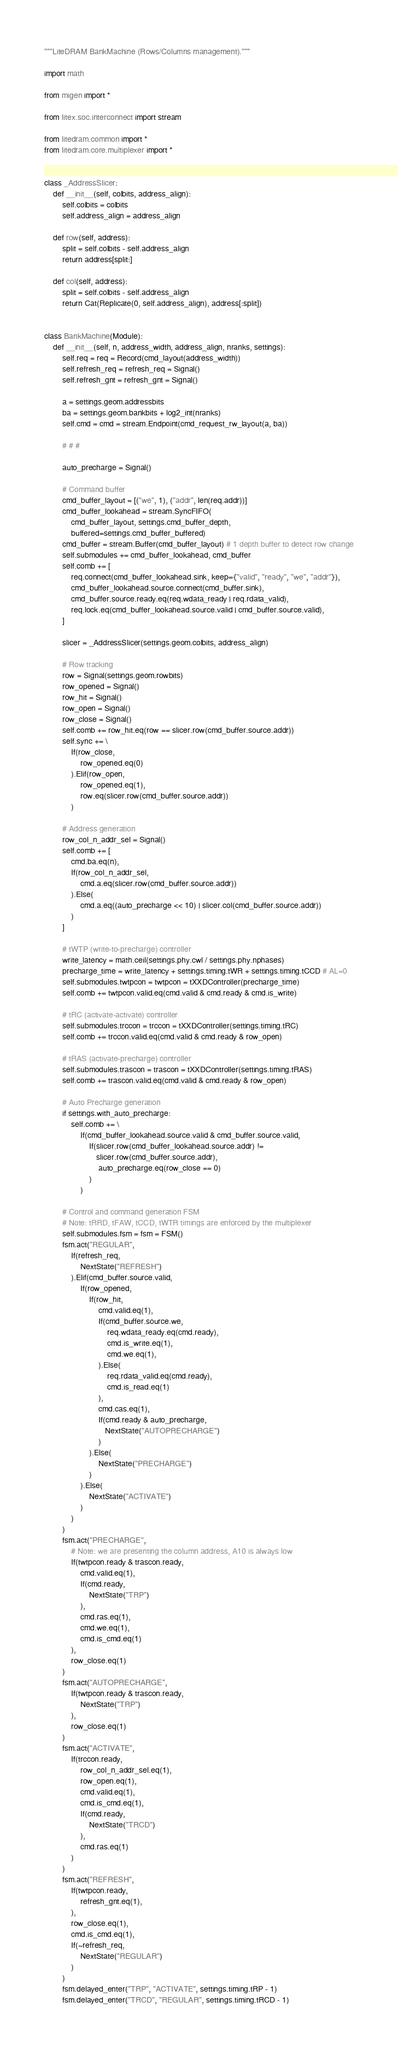<code> <loc_0><loc_0><loc_500><loc_500><_Python_>"""LiteDRAM BankMachine (Rows/Columns management)."""

import math

from migen import *

from litex.soc.interconnect import stream

from litedram.common import *
from litedram.core.multiplexer import *


class _AddressSlicer:
    def __init__(self, colbits, address_align):
        self.colbits = colbits
        self.address_align = address_align

    def row(self, address):
        split = self.colbits - self.address_align
        return address[split:]

    def col(self, address):
        split = self.colbits - self.address_align
        return Cat(Replicate(0, self.address_align), address[:split])


class BankMachine(Module):
    def __init__(self, n, address_width, address_align, nranks, settings):
        self.req = req = Record(cmd_layout(address_width))
        self.refresh_req = refresh_req = Signal()
        self.refresh_gnt = refresh_gnt = Signal()

        a = settings.geom.addressbits
        ba = settings.geom.bankbits + log2_int(nranks)
        self.cmd = cmd = stream.Endpoint(cmd_request_rw_layout(a, ba))

        # # #

        auto_precharge = Signal()

        # Command buffer
        cmd_buffer_layout = [("we", 1), ("addr", len(req.addr))]
        cmd_buffer_lookahead = stream.SyncFIFO(
            cmd_buffer_layout, settings.cmd_buffer_depth,
            buffered=settings.cmd_buffer_buffered)
        cmd_buffer = stream.Buffer(cmd_buffer_layout) # 1 depth buffer to detect row change
        self.submodules += cmd_buffer_lookahead, cmd_buffer
        self.comb += [
            req.connect(cmd_buffer_lookahead.sink, keep={"valid", "ready", "we", "addr"}),
            cmd_buffer_lookahead.source.connect(cmd_buffer.sink),
            cmd_buffer.source.ready.eq(req.wdata_ready | req.rdata_valid),
            req.lock.eq(cmd_buffer_lookahead.source.valid | cmd_buffer.source.valid),
        ]

        slicer = _AddressSlicer(settings.geom.colbits, address_align)

        # Row tracking
        row = Signal(settings.geom.rowbits)
        row_opened = Signal()
        row_hit = Signal()
        row_open = Signal()
        row_close = Signal()
        self.comb += row_hit.eq(row == slicer.row(cmd_buffer.source.addr))
        self.sync += \
            If(row_close,
                row_opened.eq(0)
            ).Elif(row_open,
                row_opened.eq(1),
                row.eq(slicer.row(cmd_buffer.source.addr))
            )

        # Address generation
        row_col_n_addr_sel = Signal()
        self.comb += [
            cmd.ba.eq(n),
            If(row_col_n_addr_sel,
                cmd.a.eq(slicer.row(cmd_buffer.source.addr))
            ).Else(
                cmd.a.eq((auto_precharge << 10) | slicer.col(cmd_buffer.source.addr))
            )
        ]

        # tWTP (write-to-precharge) controller
        write_latency = math.ceil(settings.phy.cwl / settings.phy.nphases)
        precharge_time = write_latency + settings.timing.tWR + settings.timing.tCCD # AL=0
        self.submodules.twtpcon = twtpcon = tXXDController(precharge_time)
        self.comb += twtpcon.valid.eq(cmd.valid & cmd.ready & cmd.is_write)

        # tRC (activate-activate) controller
        self.submodules.trccon = trccon = tXXDController(settings.timing.tRC)
        self.comb += trccon.valid.eq(cmd.valid & cmd.ready & row_open)

        # tRAS (activate-precharge) controller
        self.submodules.trascon = trascon = tXXDController(settings.timing.tRAS)
        self.comb += trascon.valid.eq(cmd.valid & cmd.ready & row_open)

        # Auto Precharge generation
        if settings.with_auto_precharge:
            self.comb += \
                If(cmd_buffer_lookahead.source.valid & cmd_buffer.source.valid,
                    If(slicer.row(cmd_buffer_lookahead.source.addr) !=
                       slicer.row(cmd_buffer.source.addr),
                        auto_precharge.eq(row_close == 0)
                    )
                )

        # Control and command generation FSM
        # Note: tRRD, tFAW, tCCD, tWTR timings are enforced by the multiplexer
        self.submodules.fsm = fsm = FSM()
        fsm.act("REGULAR",
            If(refresh_req,
                NextState("REFRESH")
            ).Elif(cmd_buffer.source.valid,
                If(row_opened,
                    If(row_hit,
                        cmd.valid.eq(1),
                        If(cmd_buffer.source.we,
                            req.wdata_ready.eq(cmd.ready),
                            cmd.is_write.eq(1),
                            cmd.we.eq(1),
                        ).Else(
                            req.rdata_valid.eq(cmd.ready),
                            cmd.is_read.eq(1)
                        ),
                        cmd.cas.eq(1),
                        If(cmd.ready & auto_precharge,
                           NextState("AUTOPRECHARGE")
                        )
                    ).Else(
                        NextState("PRECHARGE")
                    )
                ).Else(
                    NextState("ACTIVATE")
                )
            )
        )
        fsm.act("PRECHARGE",
            # Note: we are presenting the column address, A10 is always low
            If(twtpcon.ready & trascon.ready,
                cmd.valid.eq(1),
                If(cmd.ready,
                    NextState("TRP")
                ),
                cmd.ras.eq(1),
                cmd.we.eq(1),
                cmd.is_cmd.eq(1)
            ),
            row_close.eq(1)
        )
        fsm.act("AUTOPRECHARGE",
            If(twtpcon.ready & trascon.ready,
                NextState("TRP")
            ),
            row_close.eq(1)
        )
        fsm.act("ACTIVATE",
            If(trccon.ready,
                row_col_n_addr_sel.eq(1),
                row_open.eq(1),
                cmd.valid.eq(1),
                cmd.is_cmd.eq(1),
                If(cmd.ready,
                    NextState("TRCD")
                ),
                cmd.ras.eq(1)
            )
        )
        fsm.act("REFRESH",
            If(twtpcon.ready,
                refresh_gnt.eq(1),
            ),
            row_close.eq(1),
            cmd.is_cmd.eq(1),
            If(~refresh_req,
                NextState("REGULAR")
            )
        )
        fsm.delayed_enter("TRP", "ACTIVATE", settings.timing.tRP - 1)
        fsm.delayed_enter("TRCD", "REGULAR", settings.timing.tRCD - 1)
</code> 